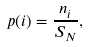<formula> <loc_0><loc_0><loc_500><loc_500>p ( i ) = \frac { n _ { i } } { S _ { N } } ,</formula> 